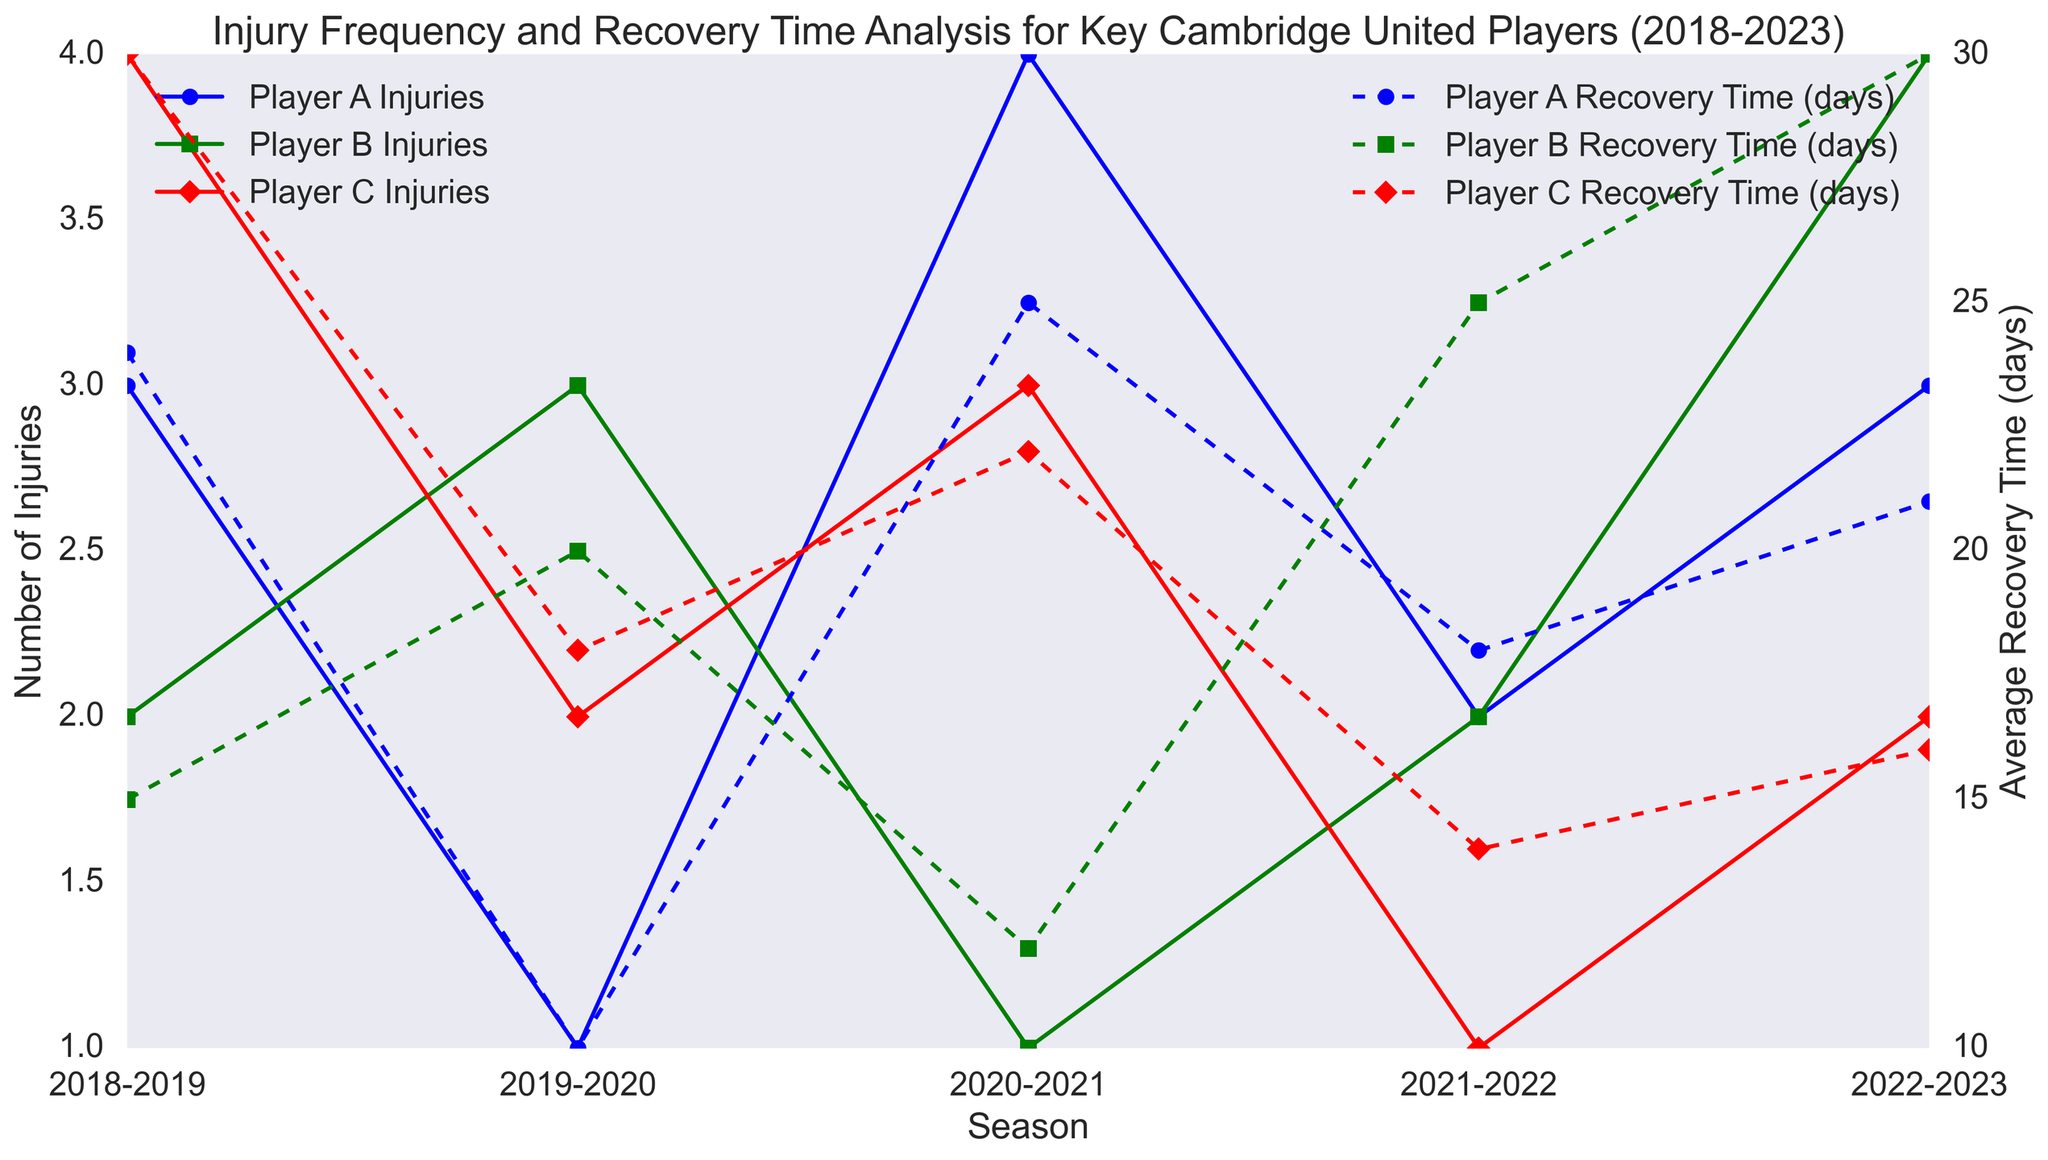What is the average number of injuries for Player B over the seasons? List the number of injuries for Player B over each season: 2, 3, 1, 2, 4. Add them up to get 2 + 3 + 1 + 2 + 4 = 12. There are 5 seasons, so divide 12 by 5 to get the average: 12 / 5 = 2.4
Answer: 2.4 Which season did Player A have the highest number of injuries? Look at the number of injuries for Player A across each season. The values are 3, 1, 4, 2, 3. The highest number is 4 in the 2020-2021 season.
Answer: 2020-2021 In which season did Player C have the shortest average recovery time? Check Player C's average recovery times across the seasons: 30, 18, 22, 14, 16. The shortest recovery time is 14 days in the 2021-2022 season.
Answer: 2021-2022 How does the recovery time for Player B in the 2022-2023 season compare to the previous seasons? Look at the recovery times for Player B for all seasons: 15, 20, 12, 25, 30. 30 days in the 2022-2023 season is the longest recovery time compared to other seasons.
Answer: 30 days is the longest What is the total number of injuries for Player A over all the seasons? Sum up the number of injuries for Player A: 3 + 1 + 4 + 2 + 3. The total is 13.
Answer: 13 Which player had the highest average recovery time in the 2018-2019 season? Compare the recovery times for the 2018-2019 season: Player A (24 days), Player B (15 days), Player C (30 days). Player C had the highest average recovery time of 30 days.
Answer: Player C In which season does Player B have the shortest recovery time and how long was it? Look at the recovery times for Player B: 15, 20, 12, 25, 30. The shortest recovery time is 12 days in the 2020-2021 season.
Answer: 2020-2021, 12 days By how many injuries did the count for Player A change between the 2019-2020 and 2020-2021 seasons? Subtract the number of injuries in 2019-2020 (1) from the number in 2020-2021 (4): 4 - 1 = 3.
Answer: Increased by 3 injuries Compare the changes in recovery time for Player C from 2019-2020 to 2020-2021 and from 2020-2021 to 2021-2022. Player C's recovery time changed from 18 days in 2019-2020 to 22 days in 2020-2021, an increase of 4 days. From 22 days in 2020-2021 to 14 days in 2021-2022 is a decrease of 8 days.
Answer: +4 days, -8 days What is the difference in recovery time for Player A between the 2018-2019 and 2022-2023 seasons? Recovery time for Player A is 24 days in 2018-2019 and 21 days in 2022-2023. The difference is 24 - 21 = 3 days.
Answer: 3 days 